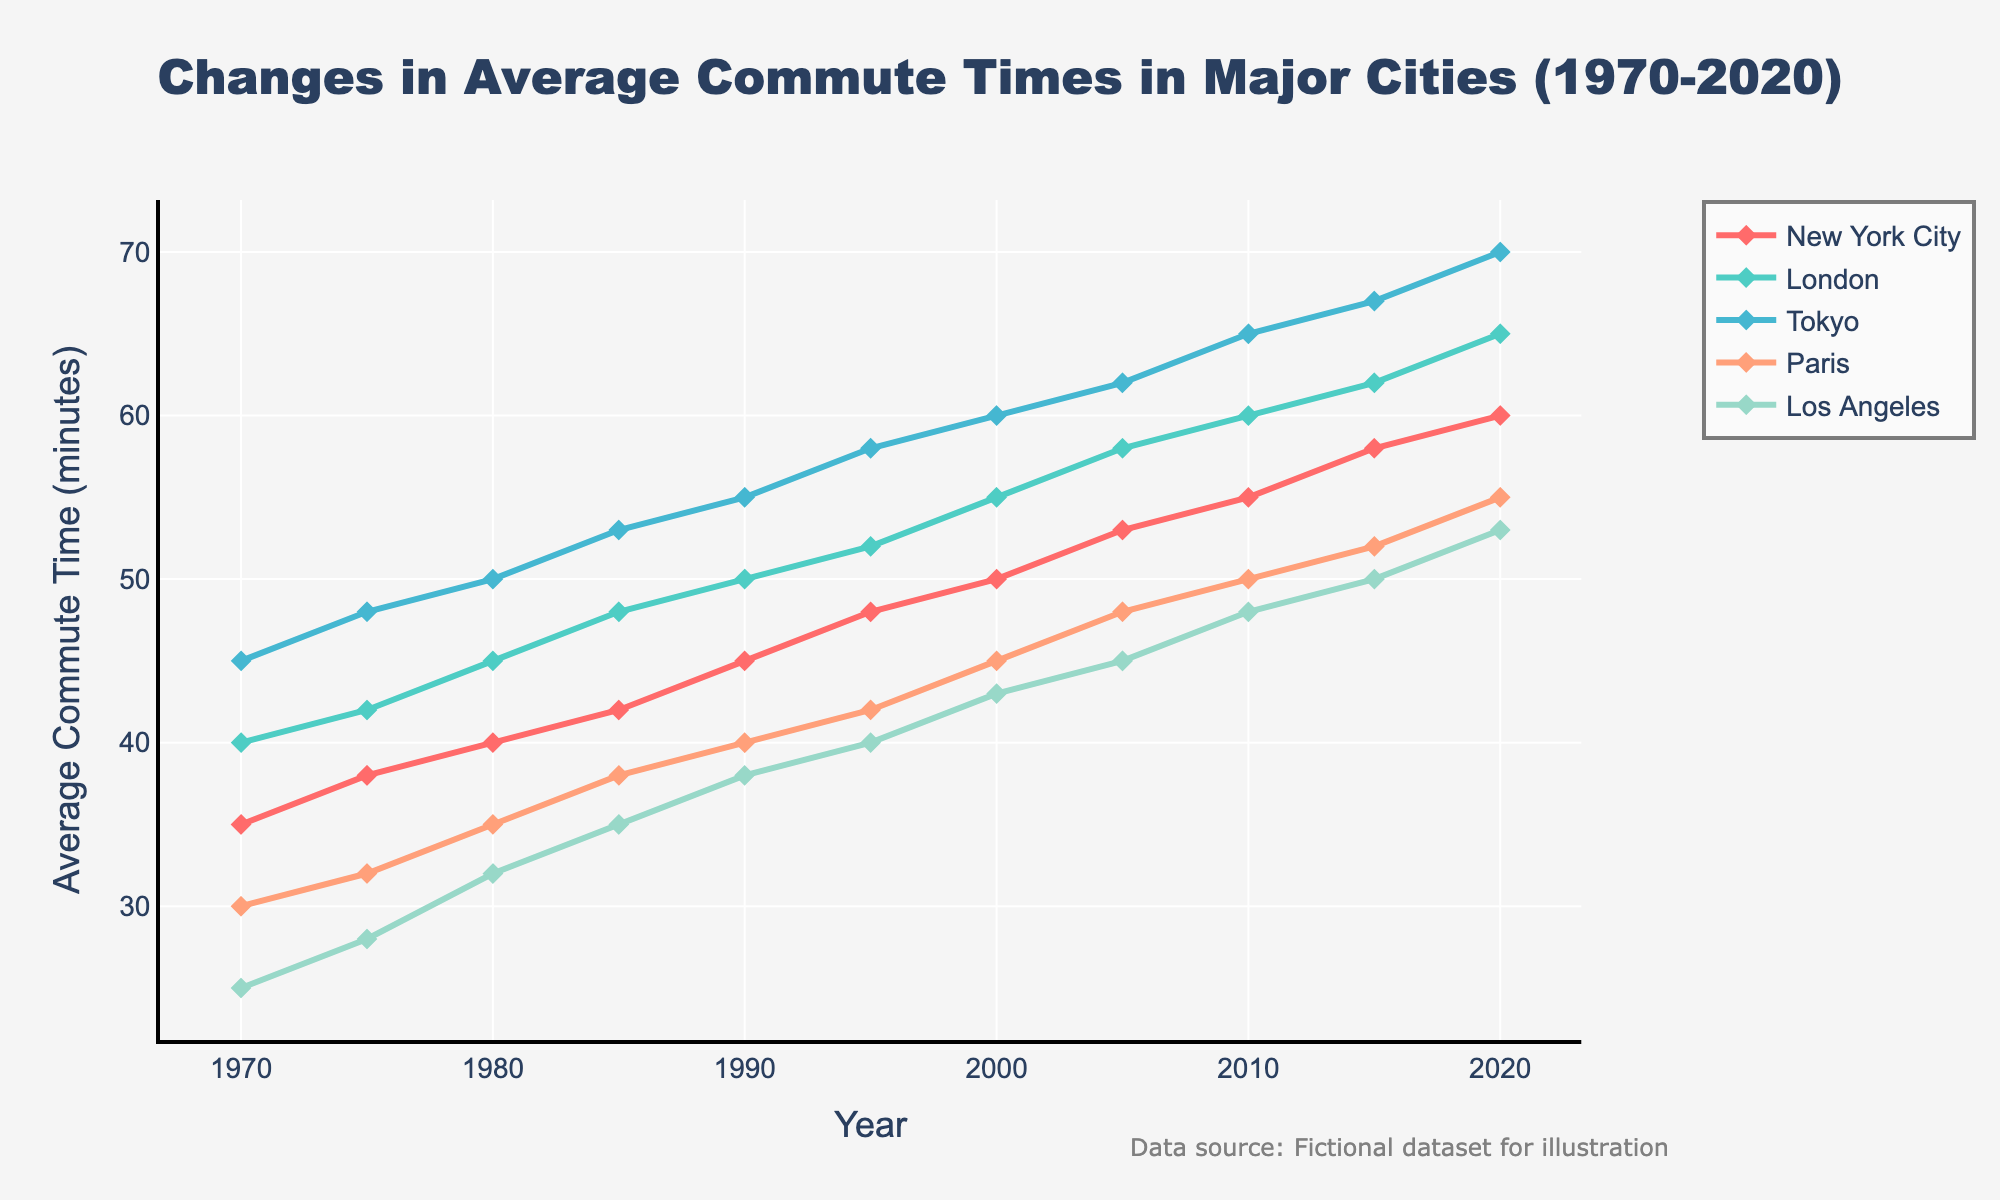What is the general trend of average commute times in New York City from 1970 to 2020? The line for New York City shows a consistent upward trend from 35 minutes in 1970 to 60 minutes in 2020. The slope of the line remains generally constant, indicating a steady increase in commute times over the years.
Answer: Increasing By how many minutes did the average commute time in London increase from 1970 to 2020? To find the increase, subtract the 1970 value from the 2020 value for London. The average commute time in London was 40 minutes in 1970 and increased to 65 minutes in 2020. So, the increase is 65 - 40 = 25 minutes.
Answer: 25 minutes Which city had the highest average commute time in 2020? The graph shows that Tokyo had the highest average commute time in 2020, reaching 70 minutes, compared to the other cities.
Answer: Tokyo Compare the average commute time of Paris in 2020 with that of Los Angeles in 2020. Which city had a longer average commute time, and by how many minutes? In 2020, the average commute time in Paris was 55 minutes, while in Los Angeles it was 53 minutes. Subtract the times to find the difference: 55 - 53 = 2 minutes. Paris had a longer average commute time by 2 minutes.
Answer: Paris, 2 minutes What is the difference in average commute times between Tokyo and Los Angeles in 1995? The average commute time in Tokyo in 1995 was 58 minutes, and in Los Angeles, it was 40 minutes. Subtract the times to find the difference: 58 - 40 = 18 minutes.
Answer: 18 minutes What is the average of the average commute times for all cities in 1985? Add the average commute times for all cities in 1985 and divide by the number of cities. The values are 42 (NYC) + 48 (London) + 53 (Tokyo) + 38 (Paris) + 35 (LA). Sum is 216. Divide by 5 cities: 216 / 5 = 43.2 minutes.
Answer: 43.2 minutes Which city showed the fastest growth in average commute times between 2000 and 2010? The growth is calculated as the difference between 2010 and 2000 commute times for each city: NYC (55-50=5), London (60-55=5), Tokyo (65-60=5), Paris (50-45=5), LA (48-43=5). All cities have the same growth of 5 minutes.
Answer: All cities How did the average commute time in Los Angeles change from 1970 to 2005? Los Angeles' average commute time increased from 25 minutes in 1970 to 45 minutes in 2005. The change is calculated as 45 - 25 = 20 minutes.
Answer: Increased by 20 minutes Which city had the smallest increase in commute time from 1970 to 2020? Calculate the increase for each city: NYC (60-35=25), London (65-40=25), Tokyo (70-45=25), Paris (55-30=25), LA (53-25=28). All cities except Los Angeles have the smallest increase of 25 minutes.
Answer: NYC, London, Tokyo, Paris 